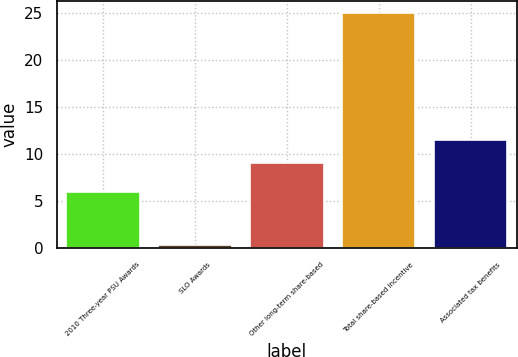<chart> <loc_0><loc_0><loc_500><loc_500><bar_chart><fcel>2010 Three-year PSU Awards<fcel>SLO Awards<fcel>Other long-term share-based<fcel>Total share-based incentive<fcel>Associated tax benefits<nl><fcel>6<fcel>0.3<fcel>9<fcel>25<fcel>11.47<nl></chart> 